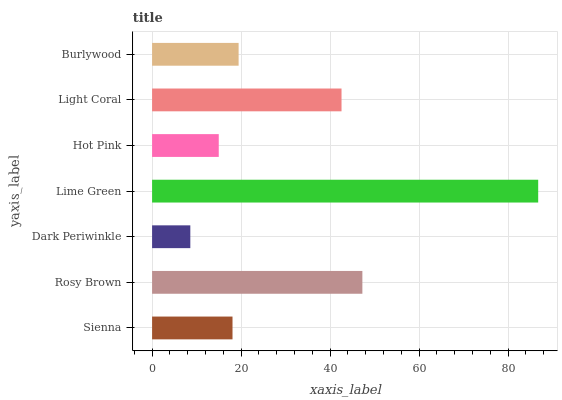Is Dark Periwinkle the minimum?
Answer yes or no. Yes. Is Lime Green the maximum?
Answer yes or no. Yes. Is Rosy Brown the minimum?
Answer yes or no. No. Is Rosy Brown the maximum?
Answer yes or no. No. Is Rosy Brown greater than Sienna?
Answer yes or no. Yes. Is Sienna less than Rosy Brown?
Answer yes or no. Yes. Is Sienna greater than Rosy Brown?
Answer yes or no. No. Is Rosy Brown less than Sienna?
Answer yes or no. No. Is Burlywood the high median?
Answer yes or no. Yes. Is Burlywood the low median?
Answer yes or no. Yes. Is Light Coral the high median?
Answer yes or no. No. Is Light Coral the low median?
Answer yes or no. No. 